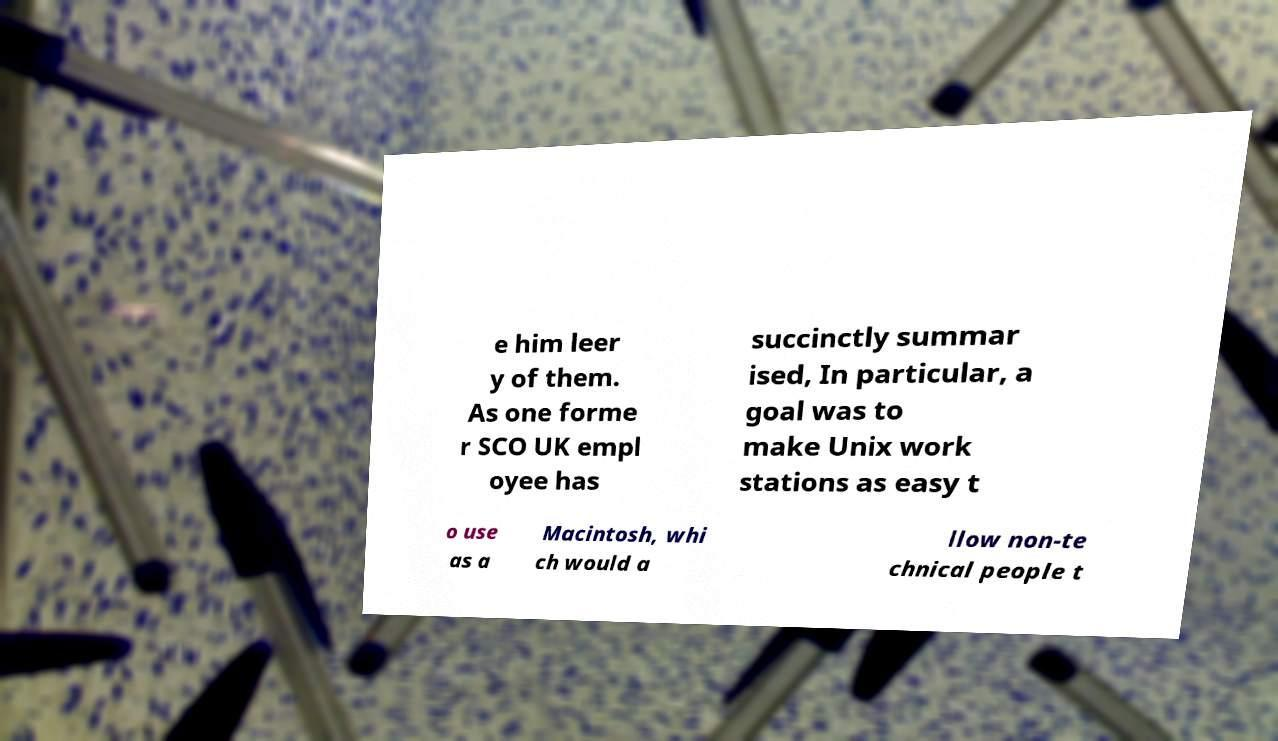There's text embedded in this image that I need extracted. Can you transcribe it verbatim? e him leer y of them. As one forme r SCO UK empl oyee has succinctly summar ised, In particular, a goal was to make Unix work stations as easy t o use as a Macintosh, whi ch would a llow non-te chnical people t 